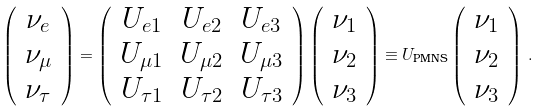<formula> <loc_0><loc_0><loc_500><loc_500>\left ( \begin{array} { c } \nu _ { e } \\ \nu _ { \mu } \\ \nu _ { \tau } \end{array} \right ) = \left ( \begin{array} { c c c } U _ { e 1 } & U _ { e 2 } & U _ { e 3 } \\ U _ { \mu 1 } & U _ { \mu 2 } & U _ { \mu 3 } \\ U _ { \tau 1 } & U _ { \tau 2 } & U _ { \tau 3 } \end{array} \right ) \left ( \begin{array} { c } \nu _ { 1 } \\ \nu _ { 2 } \\ \nu _ { 3 } \end{array} \right ) \equiv U _ { \text {PMNS} } \left ( \begin{array} { c } \nu _ { 1 } \\ \nu _ { 2 } \\ \nu _ { 3 } \end{array} \right ) \, .</formula> 